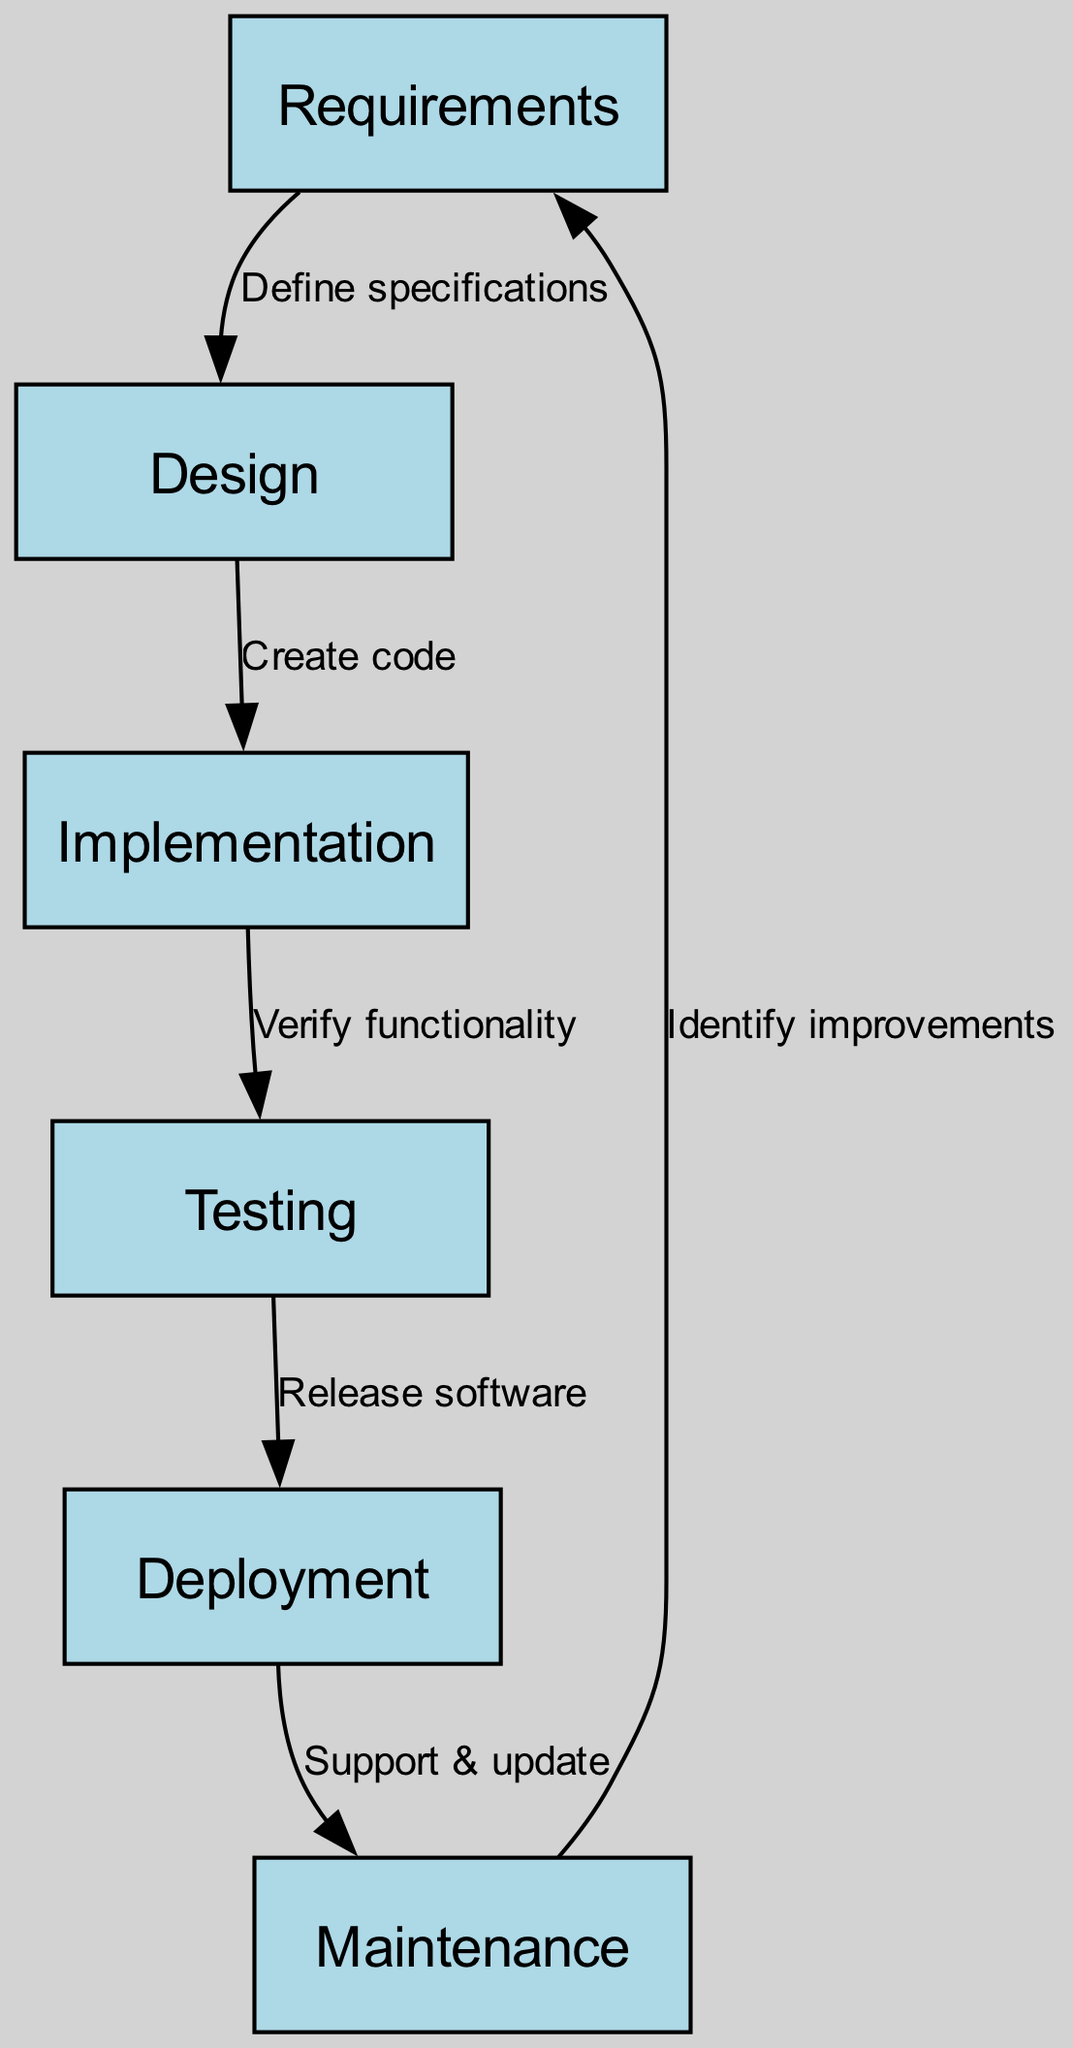What is the first step in the software development life cycle? The diagram indicates that the first step is "Requirements." This is identified by the first node in the sequence of nodes in the diagram.
Answer: Requirements How many nodes are in the diagram? By counting the nodes listed in the data, I find there are six distinct steps represented in the diagram.
Answer: 6 What is the label of the node that comes after "Design"? In the sequence of edges, "Design" is followed by the edge leading to "Implementation." Therefore, the label associated with the node that follows "Design" is "Implementation."
Answer: Implementation What process is performed between "Testing" and "Deployment"? The edge connecting these two nodes is labeled "Release software," indicating the process performed in this step.
Answer: Release software Which node leads to "Maintenance"? The diagram indicates that "Deployment" is the node that connects to "Maintenance." This is determined by following the edge from "Deployment" to "Maintenance."
Answer: Deployment How many edges are there in total in the diagram? By examining the edges listed in the data, I can see that there are five connections between the nodes, which indicates the different processes linking them.
Answer: 5 What is the last step in the software development life cycle? The last step in the cycle is "Maintenance," as per the flow of the diagram, which loops back to "Requirements."
Answer: Maintenance What is the action taken after "Implementation"? According to the diagram, after "Implementation," the action taken is "Verify functionality," which is indicated by the edge connecting the two nodes.
Answer: Verify functionality Which phase is the feedback loop connected to after "Maintenance"? The feedback loop connects back to "Requirements," as the arrows indicate a cyclical process moving from "Maintenance" to "Requirements" for improvements.
Answer: Requirements 